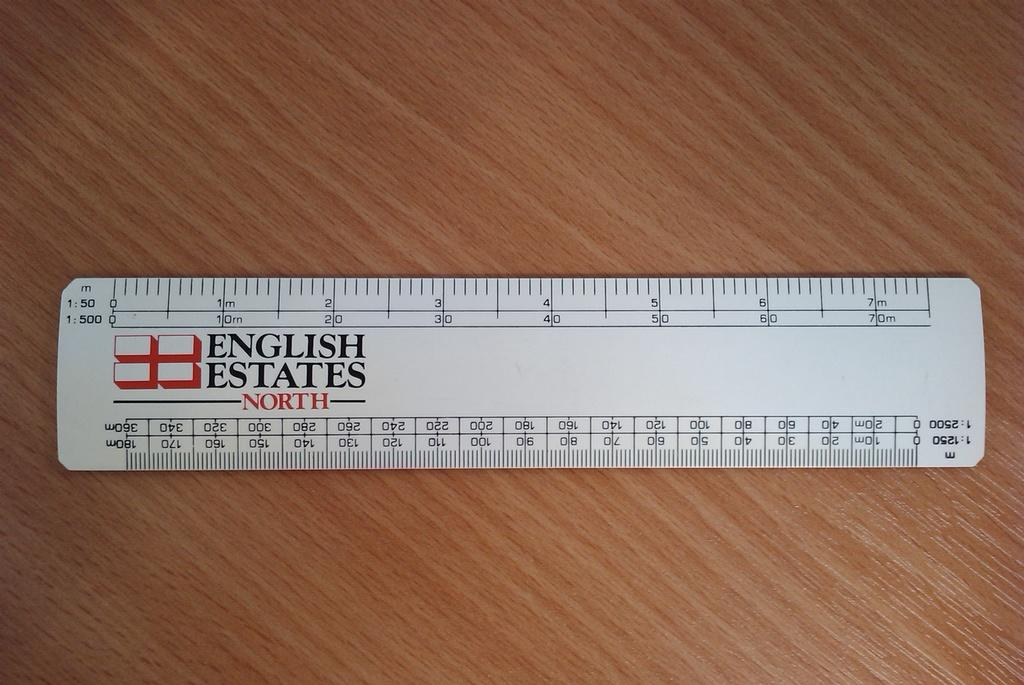Provide a one-sentence caption for the provided image. A metric ruler with the logo English States North emblazoned upon it. 